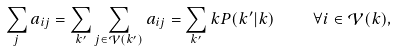Convert formula to latex. <formula><loc_0><loc_0><loc_500><loc_500>\sum _ { j } a _ { i j } = \sum _ { k ^ { \prime } } \sum _ { j \in \mathcal { V } ( k ^ { \prime } ) } a _ { i j } = \sum _ { k ^ { \prime } } k P ( k ^ { \prime } | k ) \quad \forall i \in \mathcal { V } ( k ) ,</formula> 